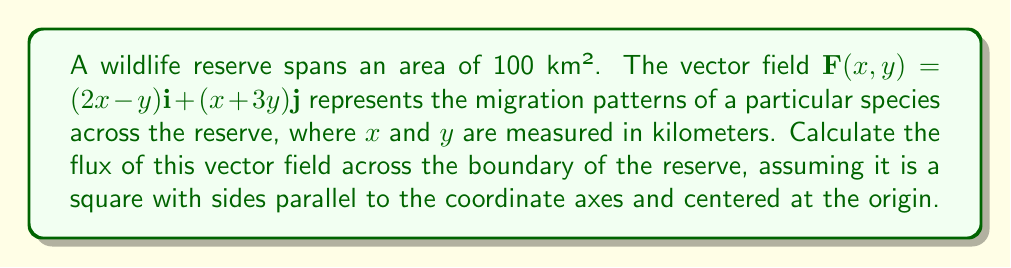Teach me how to tackle this problem. To solve this problem, we'll use the divergence theorem, which relates the flux across a closed boundary to the divergence of the vector field within the enclosed region.

1) First, we need to find the divergence of the vector field:
   $$\nabla \cdot \mathbf{F} = \frac{\partial}{\partial x}(2x-y) + \frac{\partial}{\partial y}(x+3y) = 2 + 3 = 5$$

2) The divergence is constant, which simplifies our calculation.

3) The area of the reserve is 100 km², so each side of the square is 10 km long.

4) The square extends from -5 km to 5 km in both x and y directions.

5) Now, we can apply the divergence theorem:
   $$\oint_C \mathbf{F} \cdot \mathbf{n} \, ds = \iint_R \nabla \cdot \mathbf{F} \, dA$$

   Where $C$ is the boundary of the reserve, $\mathbf{n}$ is the outward unit normal vector, and $R$ is the region enclosed by $C$.

6) Since $\nabla \cdot \mathbf{F}$ is constant, we can simplify:
   $$\oint_C \mathbf{F} \cdot \mathbf{n} \, ds = 5 \cdot \text{Area} = 5 \cdot 100 = 500$$

Therefore, the flux across the boundary of the reserve is 500 km²/time unit.
Answer: 500 km²/time unit 